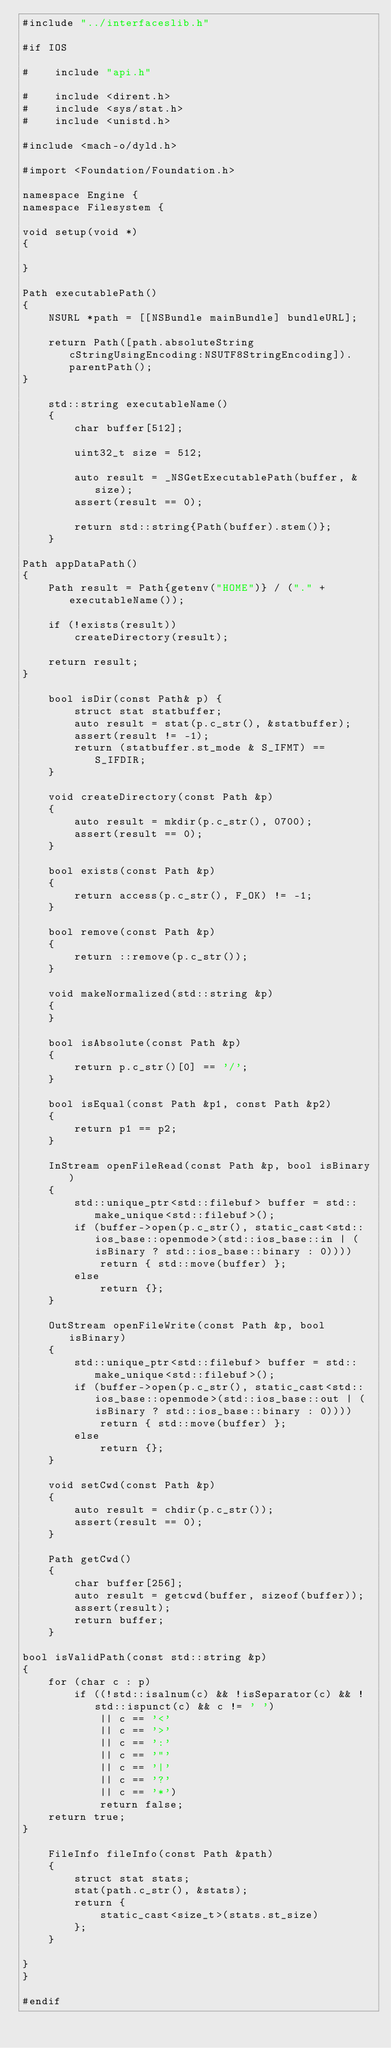<code> <loc_0><loc_0><loc_500><loc_500><_ObjectiveC_>#include "../interfaceslib.h"

#if IOS

#    include "api.h"

#    include <dirent.h>
#    include <sys/stat.h>
#    include <unistd.h>

#include <mach-o/dyld.h>

#import <Foundation/Foundation.h>

namespace Engine {
namespace Filesystem {

void setup(void *)
{
    
}

Path executablePath()
{
    NSURL *path = [[NSBundle mainBundle] bundleURL];
    
    return Path([path.absoluteString cStringUsingEncoding:NSUTF8StringEncoding]).parentPath();
}

    std::string executableName()
    {
        char buffer[512];

        uint32_t size = 512;

        auto result = _NSGetExecutablePath(buffer, &size);
        assert(result == 0);
        
        return std::string{Path(buffer).stem()};
    }

Path appDataPath()
{
    Path result = Path{getenv("HOME")} / ("." + executableName());

    if (!exists(result))
        createDirectory(result);

    return result;
}

    bool isDir(const Path& p) {
        struct stat statbuffer;
        auto result = stat(p.c_str(), &statbuffer);
        assert(result != -1);
        return (statbuffer.st_mode & S_IFMT) == S_IFDIR;
    }

    void createDirectory(const Path &p)
    {
        auto result = mkdir(p.c_str(), 0700);
        assert(result == 0);
    }

    bool exists(const Path &p)
    {
        return access(p.c_str(), F_OK) != -1;
    }

    bool remove(const Path &p)
    {
        return ::remove(p.c_str());
    }

    void makeNormalized(std::string &p)
    {        
    }

    bool isAbsolute(const Path &p)
    {
        return p.c_str()[0] == '/';
    }

    bool isEqual(const Path &p1, const Path &p2)
    {
        return p1 == p2;
    }

    InStream openFileRead(const Path &p, bool isBinary)
    {
        std::unique_ptr<std::filebuf> buffer = std::make_unique<std::filebuf>();
        if (buffer->open(p.c_str(), static_cast<std::ios_base::openmode>(std::ios_base::in | (isBinary ? std::ios_base::binary : 0))))
            return { std::move(buffer) };
        else
            return {};
    }

    OutStream openFileWrite(const Path &p, bool isBinary)
    {
        std::unique_ptr<std::filebuf> buffer = std::make_unique<std::filebuf>();
        if (buffer->open(p.c_str(), static_cast<std::ios_base::openmode>(std::ios_base::out | (isBinary ? std::ios_base::binary : 0))))
            return { std::move(buffer) };
        else
            return {};
    }

    void setCwd(const Path &p)
    {
        auto result = chdir(p.c_str());
        assert(result == 0);
    }

    Path getCwd()
    {
        char buffer[256];
        auto result = getcwd(buffer, sizeof(buffer));
        assert(result);
        return buffer;
    }

bool isValidPath(const std::string &p)
{
    for (char c : p)
        if ((!std::isalnum(c) && !isSeparator(c) && !std::ispunct(c) && c != ' ')
            || c == '<'
            || c == '>'
            || c == ':'
            || c == '"'
            || c == '|'
            || c == '?'
            || c == '*')
            return false;
    return true;
}

    FileInfo fileInfo(const Path &path)
    {
        struct stat stats;
        stat(path.c_str(), &stats);
        return {
            static_cast<size_t>(stats.st_size)
        };
    }

}
}

#endif
</code> 